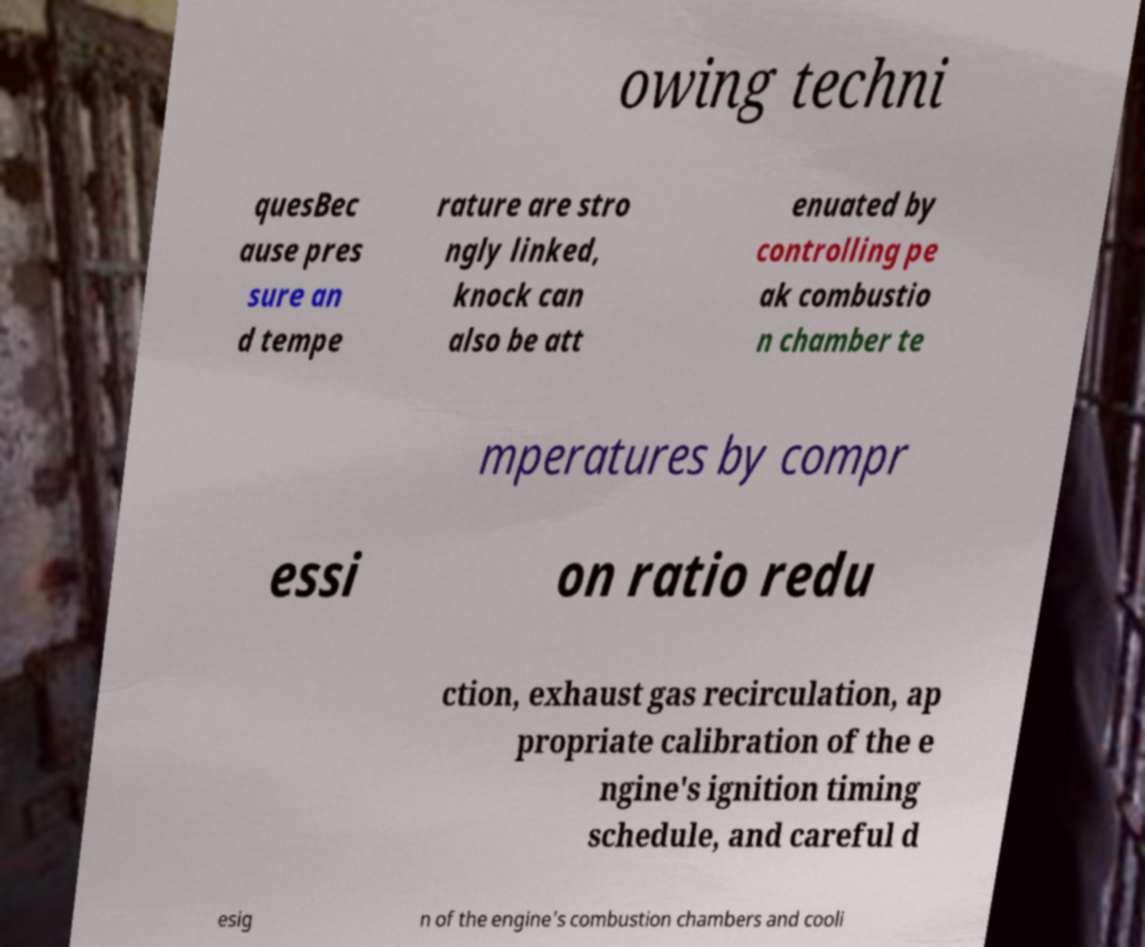Could you assist in decoding the text presented in this image and type it out clearly? owing techni quesBec ause pres sure an d tempe rature are stro ngly linked, knock can also be att enuated by controlling pe ak combustio n chamber te mperatures by compr essi on ratio redu ction, exhaust gas recirculation, ap propriate calibration of the e ngine's ignition timing schedule, and careful d esig n of the engine's combustion chambers and cooli 